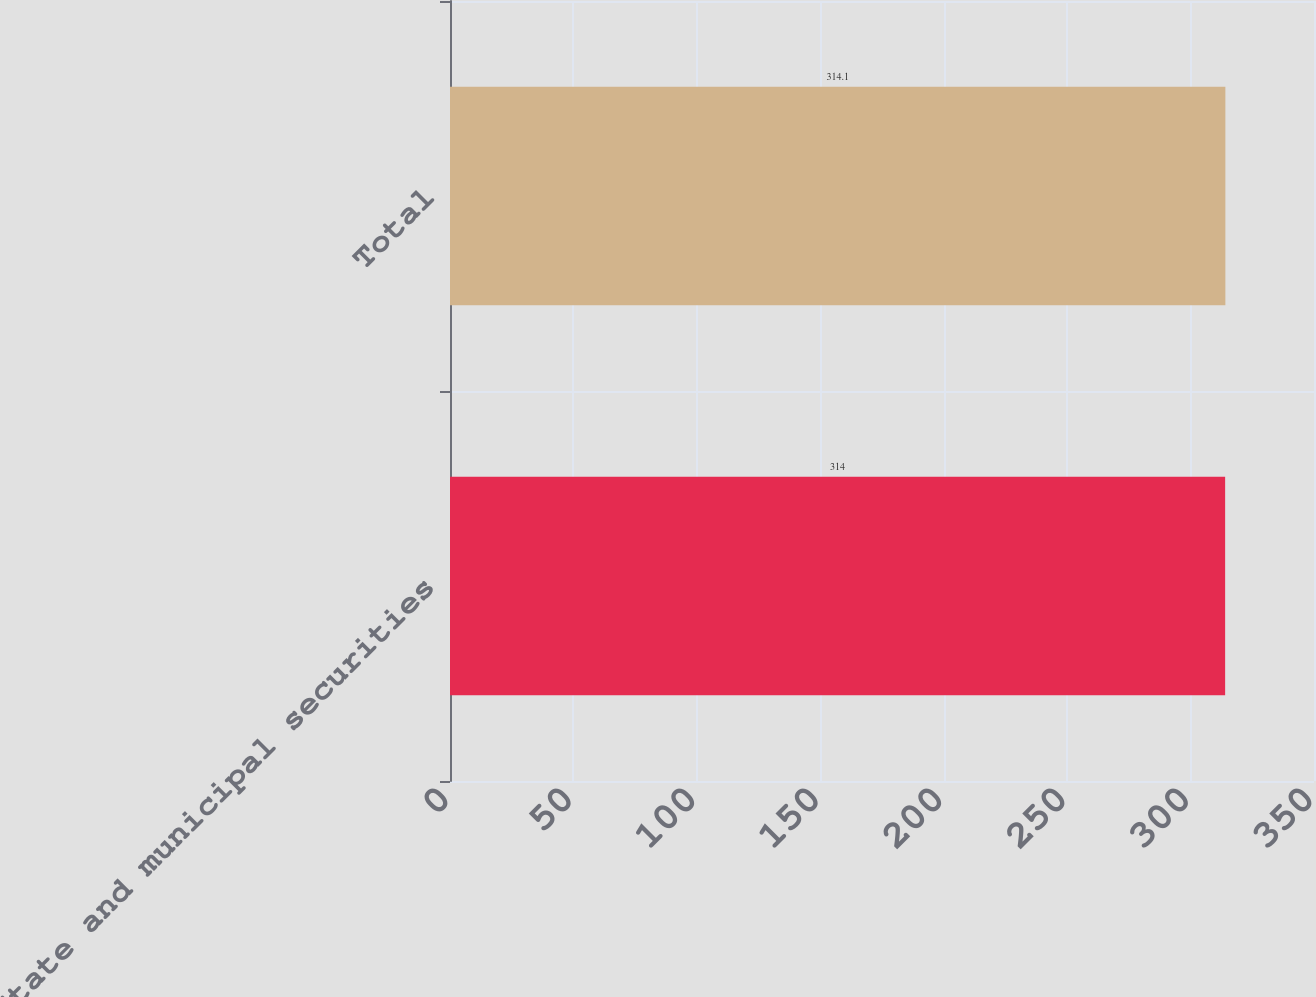Convert chart. <chart><loc_0><loc_0><loc_500><loc_500><bar_chart><fcel>State and municipal securities<fcel>Total<nl><fcel>314<fcel>314.1<nl></chart> 